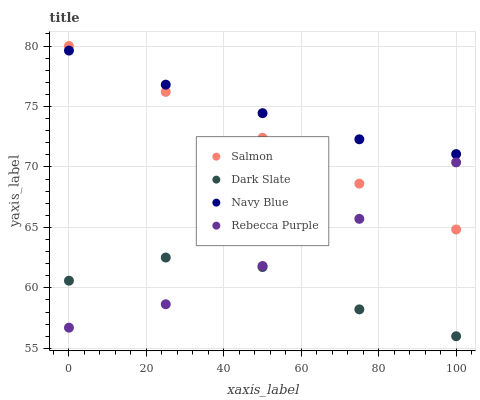Does Dark Slate have the minimum area under the curve?
Answer yes or no. Yes. Does Navy Blue have the maximum area under the curve?
Answer yes or no. Yes. Does Salmon have the minimum area under the curve?
Answer yes or no. No. Does Salmon have the maximum area under the curve?
Answer yes or no. No. Is Salmon the smoothest?
Answer yes or no. Yes. Is Dark Slate the roughest?
Answer yes or no. Yes. Is Rebecca Purple the smoothest?
Answer yes or no. No. Is Rebecca Purple the roughest?
Answer yes or no. No. Does Dark Slate have the lowest value?
Answer yes or no. Yes. Does Salmon have the lowest value?
Answer yes or no. No. Does Salmon have the highest value?
Answer yes or no. Yes. Does Rebecca Purple have the highest value?
Answer yes or no. No. Is Dark Slate less than Salmon?
Answer yes or no. Yes. Is Navy Blue greater than Rebecca Purple?
Answer yes or no. Yes. Does Rebecca Purple intersect Dark Slate?
Answer yes or no. Yes. Is Rebecca Purple less than Dark Slate?
Answer yes or no. No. Is Rebecca Purple greater than Dark Slate?
Answer yes or no. No. Does Dark Slate intersect Salmon?
Answer yes or no. No. 